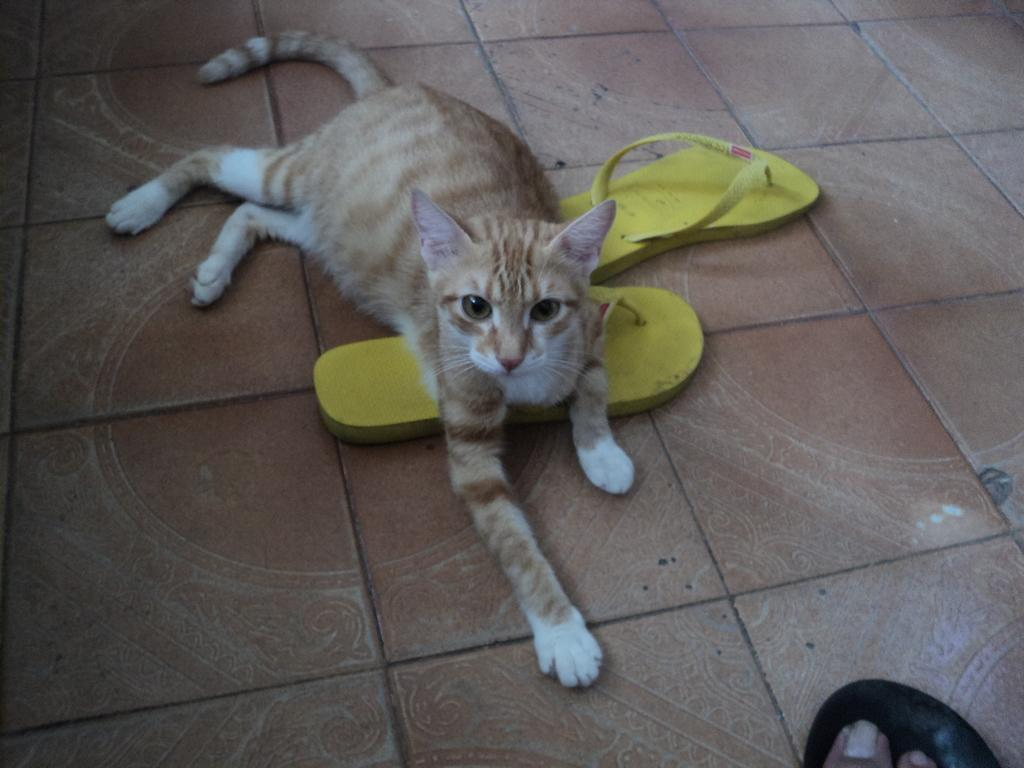What animal can be seen in the image? There is a cat in the image. What position is the cat in? The cat is lying on the floor. What type of footwear is near the cat? There is yellow color footwear near the cat. Can you see the cat attacking the roof in the image? There is no cat attacking the roof in the image; the cat is lying on the floor. Is the ocean visible in the image? The ocean is not visible in the image; it only features a cat, the cat's position, and yellow footwear. 